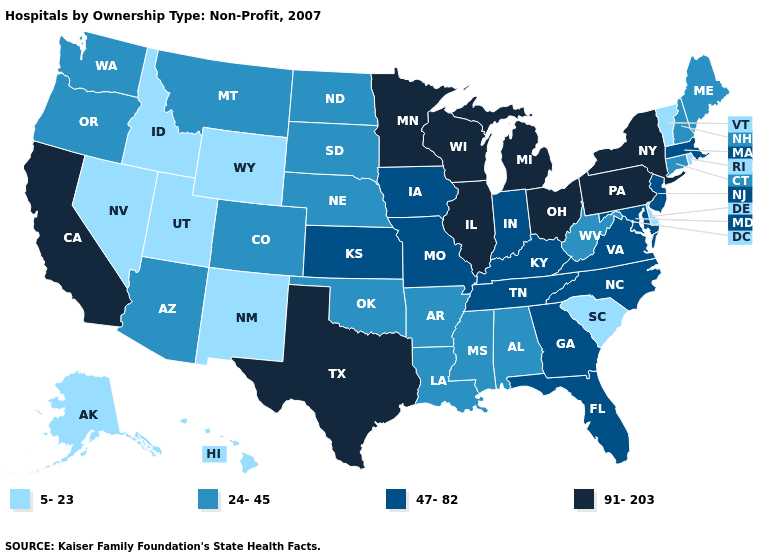What is the value of Missouri?
Short answer required. 47-82. What is the value of Georgia?
Concise answer only. 47-82. Does the map have missing data?
Concise answer only. No. What is the value of Rhode Island?
Write a very short answer. 5-23. Name the states that have a value in the range 24-45?
Be succinct. Alabama, Arizona, Arkansas, Colorado, Connecticut, Louisiana, Maine, Mississippi, Montana, Nebraska, New Hampshire, North Dakota, Oklahoma, Oregon, South Dakota, Washington, West Virginia. What is the value of Maine?
Be succinct. 24-45. Name the states that have a value in the range 24-45?
Be succinct. Alabama, Arizona, Arkansas, Colorado, Connecticut, Louisiana, Maine, Mississippi, Montana, Nebraska, New Hampshire, North Dakota, Oklahoma, Oregon, South Dakota, Washington, West Virginia. What is the value of Oregon?
Answer briefly. 24-45. What is the lowest value in states that border New Mexico?
Quick response, please. 5-23. Does Illinois have a lower value than Oregon?
Answer briefly. No. Which states hav the highest value in the MidWest?
Short answer required. Illinois, Michigan, Minnesota, Ohio, Wisconsin. Name the states that have a value in the range 5-23?
Keep it brief. Alaska, Delaware, Hawaii, Idaho, Nevada, New Mexico, Rhode Island, South Carolina, Utah, Vermont, Wyoming. What is the highest value in the MidWest ?
Short answer required. 91-203. Does Alaska have a lower value than South Carolina?
Give a very brief answer. No. Which states have the highest value in the USA?
Keep it brief. California, Illinois, Michigan, Minnesota, New York, Ohio, Pennsylvania, Texas, Wisconsin. 